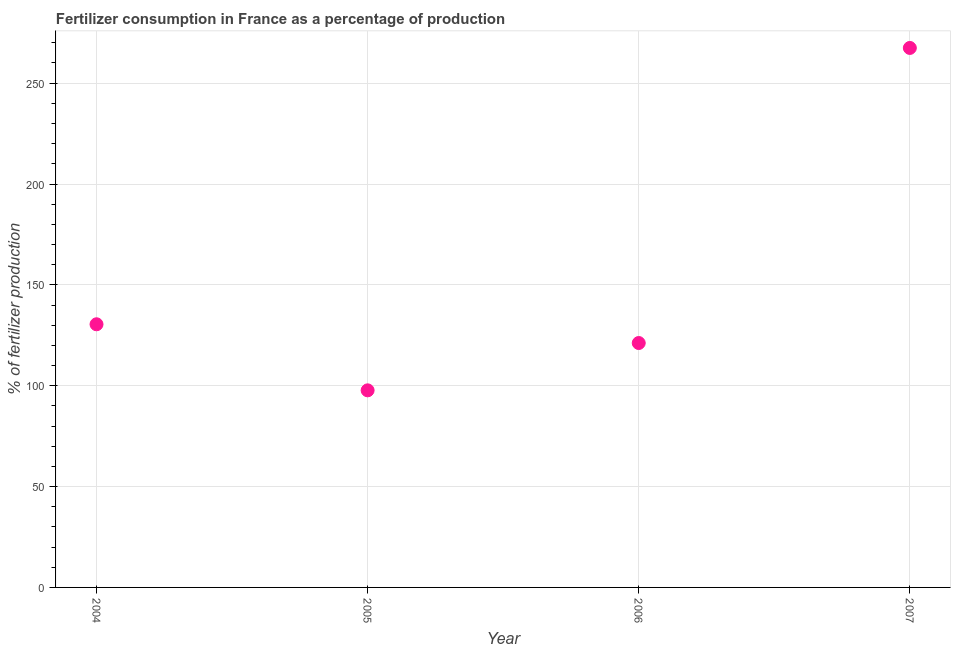What is the amount of fertilizer consumption in 2005?
Give a very brief answer. 97.71. Across all years, what is the maximum amount of fertilizer consumption?
Your response must be concise. 267.46. Across all years, what is the minimum amount of fertilizer consumption?
Offer a very short reply. 97.71. In which year was the amount of fertilizer consumption maximum?
Provide a short and direct response. 2007. What is the sum of the amount of fertilizer consumption?
Make the answer very short. 616.8. What is the difference between the amount of fertilizer consumption in 2005 and 2006?
Your response must be concise. -23.46. What is the average amount of fertilizer consumption per year?
Make the answer very short. 154.2. What is the median amount of fertilizer consumption?
Ensure brevity in your answer.  125.82. In how many years, is the amount of fertilizer consumption greater than 140 %?
Offer a terse response. 1. Do a majority of the years between 2007 and 2005 (inclusive) have amount of fertilizer consumption greater than 30 %?
Provide a short and direct response. No. What is the ratio of the amount of fertilizer consumption in 2006 to that in 2007?
Keep it short and to the point. 0.45. What is the difference between the highest and the second highest amount of fertilizer consumption?
Provide a short and direct response. 137. What is the difference between the highest and the lowest amount of fertilizer consumption?
Offer a very short reply. 169.75. In how many years, is the amount of fertilizer consumption greater than the average amount of fertilizer consumption taken over all years?
Your answer should be very brief. 1. How many years are there in the graph?
Keep it short and to the point. 4. What is the difference between two consecutive major ticks on the Y-axis?
Ensure brevity in your answer.  50. Are the values on the major ticks of Y-axis written in scientific E-notation?
Provide a succinct answer. No. Does the graph contain grids?
Give a very brief answer. Yes. What is the title of the graph?
Offer a terse response. Fertilizer consumption in France as a percentage of production. What is the label or title of the Y-axis?
Your answer should be compact. % of fertilizer production. What is the % of fertilizer production in 2004?
Offer a terse response. 130.46. What is the % of fertilizer production in 2005?
Your answer should be compact. 97.71. What is the % of fertilizer production in 2006?
Ensure brevity in your answer.  121.17. What is the % of fertilizer production in 2007?
Provide a succinct answer. 267.46. What is the difference between the % of fertilizer production in 2004 and 2005?
Offer a very short reply. 32.75. What is the difference between the % of fertilizer production in 2004 and 2006?
Give a very brief answer. 9.29. What is the difference between the % of fertilizer production in 2004 and 2007?
Your response must be concise. -137. What is the difference between the % of fertilizer production in 2005 and 2006?
Offer a very short reply. -23.46. What is the difference between the % of fertilizer production in 2005 and 2007?
Your answer should be compact. -169.75. What is the difference between the % of fertilizer production in 2006 and 2007?
Your response must be concise. -146.29. What is the ratio of the % of fertilizer production in 2004 to that in 2005?
Keep it short and to the point. 1.33. What is the ratio of the % of fertilizer production in 2004 to that in 2006?
Give a very brief answer. 1.08. What is the ratio of the % of fertilizer production in 2004 to that in 2007?
Provide a succinct answer. 0.49. What is the ratio of the % of fertilizer production in 2005 to that in 2006?
Make the answer very short. 0.81. What is the ratio of the % of fertilizer production in 2005 to that in 2007?
Make the answer very short. 0.36. What is the ratio of the % of fertilizer production in 2006 to that in 2007?
Your answer should be compact. 0.45. 